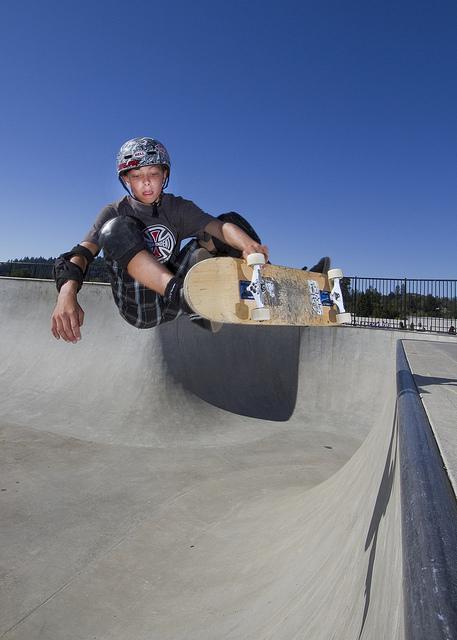Why is his head covered?
Make your selection from the four choices given to correctly answer the question.
Options: Fashion, religion, protection, warmth. Protection. 